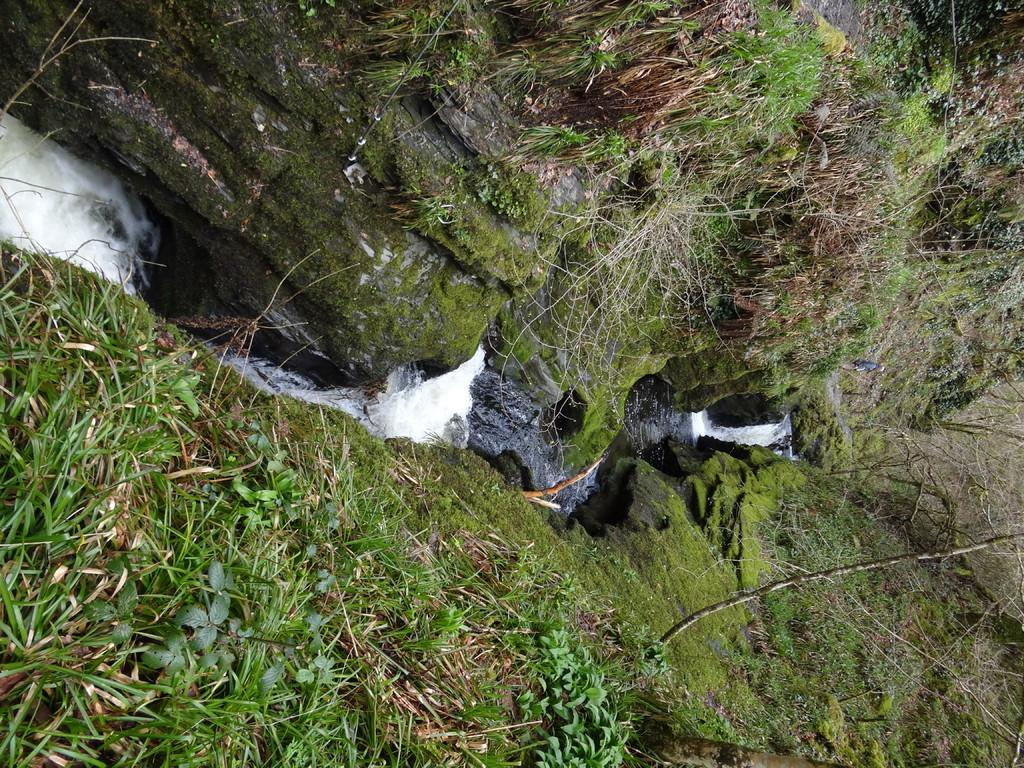What type of vegetation is present at the bottom of the image? There is grass at the bottom of the image. What type of vegetation is present at the top of the image? There is grass at the top of the image. What natural element is flowing in the middle of the image? There is water flowing in the middle of the image. How many eyes can be seen in the image? There are no eyes present in the image. What type of lunch is being prepared in the image? There is no lunch preparation visible in the image. 